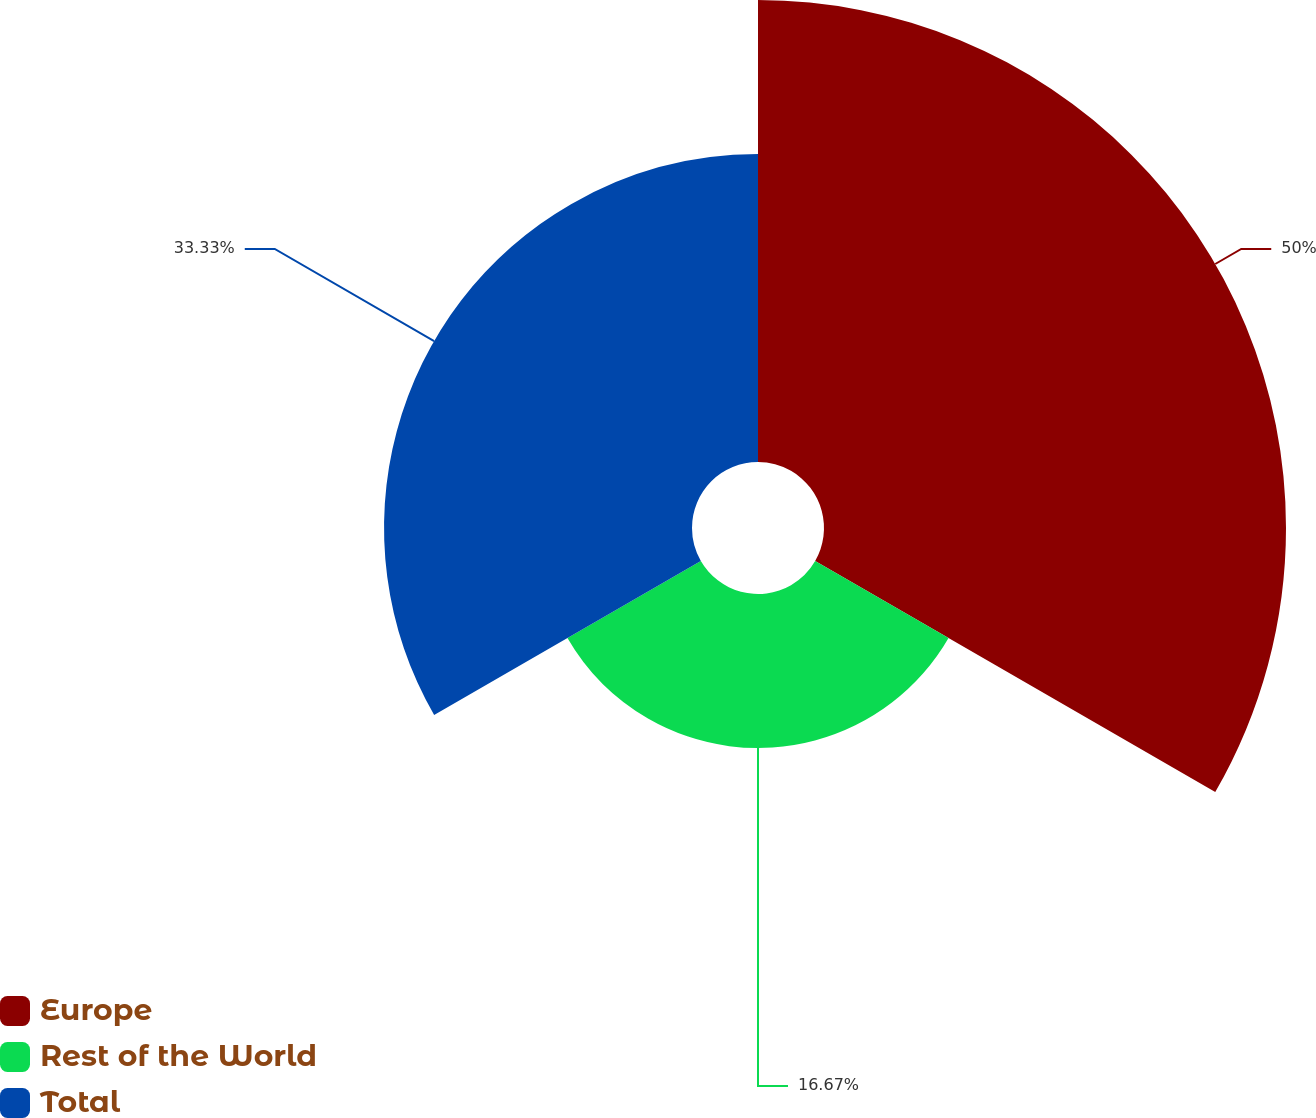Convert chart to OTSL. <chart><loc_0><loc_0><loc_500><loc_500><pie_chart><fcel>Europe<fcel>Rest of the World<fcel>Total<nl><fcel>50.0%<fcel>16.67%<fcel>33.33%<nl></chart> 